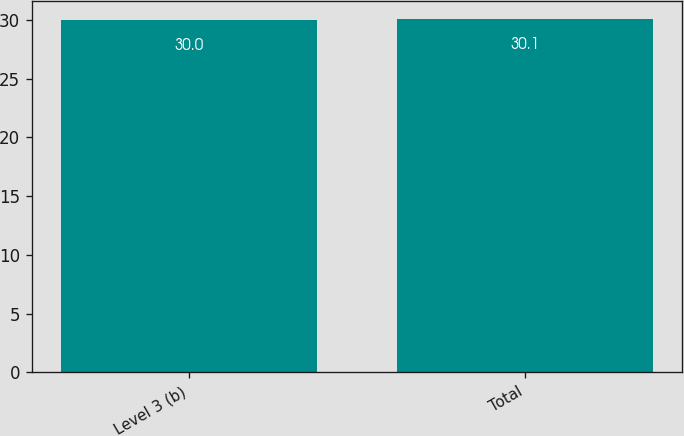Convert chart. <chart><loc_0><loc_0><loc_500><loc_500><bar_chart><fcel>Level 3 (b)<fcel>Total<nl><fcel>30<fcel>30.1<nl></chart> 